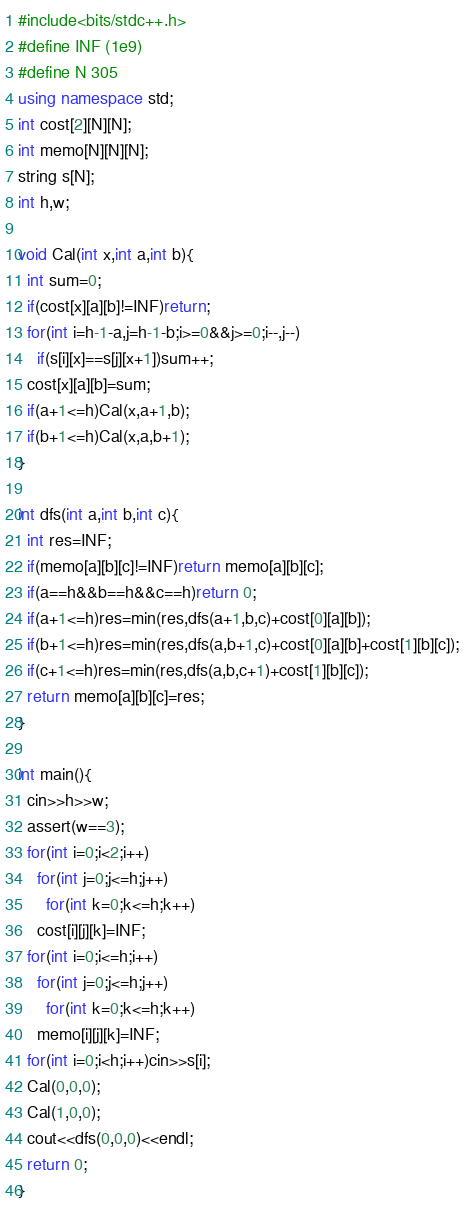<code> <loc_0><loc_0><loc_500><loc_500><_C++_>#include<bits/stdc++.h>
#define INF (1e9)
#define N 305
using namespace std;
int cost[2][N][N];
int memo[N][N][N];
string s[N];
int h,w;

void Cal(int x,int a,int b){
  int sum=0;
  if(cost[x][a][b]!=INF)return;
  for(int i=h-1-a,j=h-1-b;i>=0&&j>=0;i--,j--)
    if(s[i][x]==s[j][x+1])sum++;
  cost[x][a][b]=sum;
  if(a+1<=h)Cal(x,a+1,b);
  if(b+1<=h)Cal(x,a,b+1);
}

int dfs(int a,int b,int c){
  int res=INF;
  if(memo[a][b][c]!=INF)return memo[a][b][c];
  if(a==h&&b==h&&c==h)return 0;
  if(a+1<=h)res=min(res,dfs(a+1,b,c)+cost[0][a][b]);
  if(b+1<=h)res=min(res,dfs(a,b+1,c)+cost[0][a][b]+cost[1][b][c]);
  if(c+1<=h)res=min(res,dfs(a,b,c+1)+cost[1][b][c]);
  return memo[a][b][c]=res;
}

int main(){
  cin>>h>>w;
  assert(w==3);
  for(int i=0;i<2;i++)
    for(int j=0;j<=h;j++)
      for(int k=0;k<=h;k++)
	cost[i][j][k]=INF;
  for(int i=0;i<=h;i++)
    for(int j=0;j<=h;j++)
      for(int k=0;k<=h;k++)
	memo[i][j][k]=INF;
  for(int i=0;i<h;i++)cin>>s[i];
  Cal(0,0,0);
  Cal(1,0,0);
  cout<<dfs(0,0,0)<<endl;
  return 0;
}
</code> 